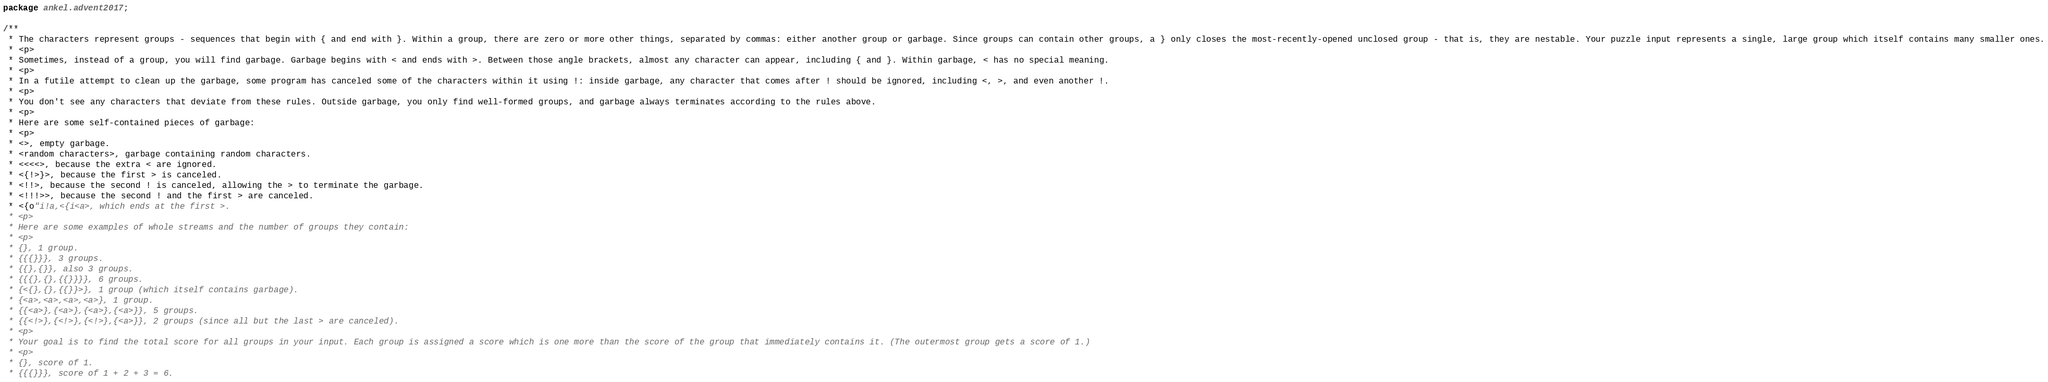<code> <loc_0><loc_0><loc_500><loc_500><_Java_>package ankel.advent2017;

/**
 * The characters represent groups - sequences that begin with { and end with }. Within a group, there are zero or more other things, separated by commas: either another group or garbage. Since groups can contain other groups, a } only closes the most-recently-opened unclosed group - that is, they are nestable. Your puzzle input represents a single, large group which itself contains many smaller ones.
 * <p>
 * Sometimes, instead of a group, you will find garbage. Garbage begins with < and ends with >. Between those angle brackets, almost any character can appear, including { and }. Within garbage, < has no special meaning.
 * <p>
 * In a futile attempt to clean up the garbage, some program has canceled some of the characters within it using !: inside garbage, any character that comes after ! should be ignored, including <, >, and even another !.
 * <p>
 * You don't see any characters that deviate from these rules. Outside garbage, you only find well-formed groups, and garbage always terminates according to the rules above.
 * <p>
 * Here are some self-contained pieces of garbage:
 * <p>
 * <>, empty garbage.
 * <random characters>, garbage containing random characters.
 * <<<<>, because the extra < are ignored.
 * <{!>}>, because the first > is canceled.
 * <!!>, because the second ! is canceled, allowing the > to terminate the garbage.
 * <!!!>>, because the second ! and the first > are canceled.
 * <{o"i!a,<{i<a>, which ends at the first >.
 * <p>
 * Here are some examples of whole streams and the number of groups they contain:
 * <p>
 * {}, 1 group.
 * {{{}}}, 3 groups.
 * {{},{}}, also 3 groups.
 * {{{},{},{{}}}}, 6 groups.
 * {<{},{},{{}}>}, 1 group (which itself contains garbage).
 * {<a>,<a>,<a>,<a>}, 1 group.
 * {{<a>},{<a>},{<a>},{<a>}}, 5 groups.
 * {{<!>},{<!>},{<!>},{<a>}}, 2 groups (since all but the last > are canceled).
 * <p>
 * Your goal is to find the total score for all groups in your input. Each group is assigned a score which is one more than the score of the group that immediately contains it. (The outermost group gets a score of 1.)
 * <p>
 * {}, score of 1.
 * {{{}}}, score of 1 + 2 + 3 = 6.</code> 